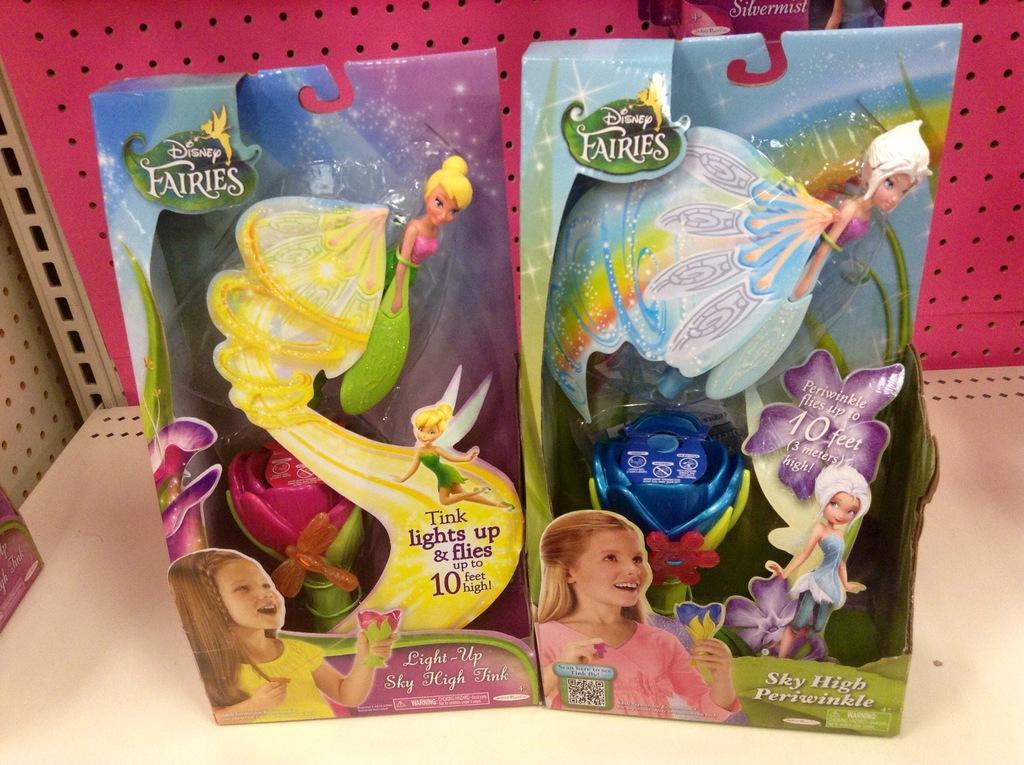Could you give a brief overview of what you see in this image? In this picture I can see boxes on the rack. 